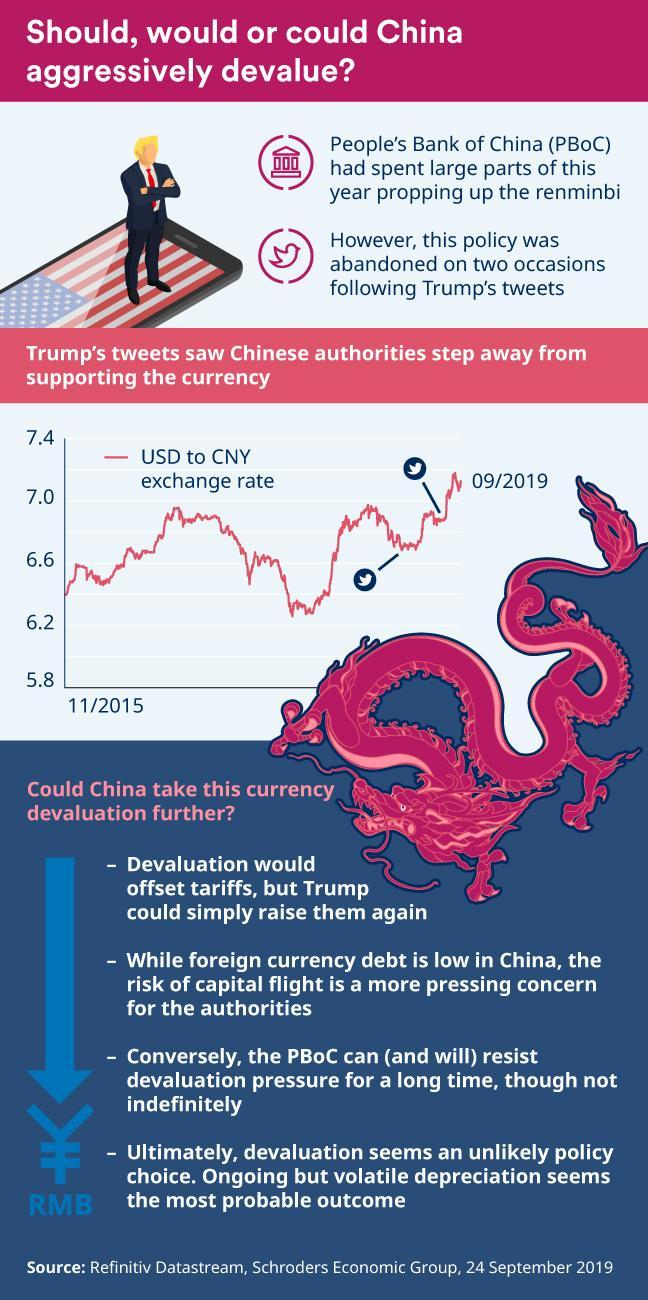How many points are under the heading "Could china take this currency devaluation further"?
Answer the question with a short phrase. 4 